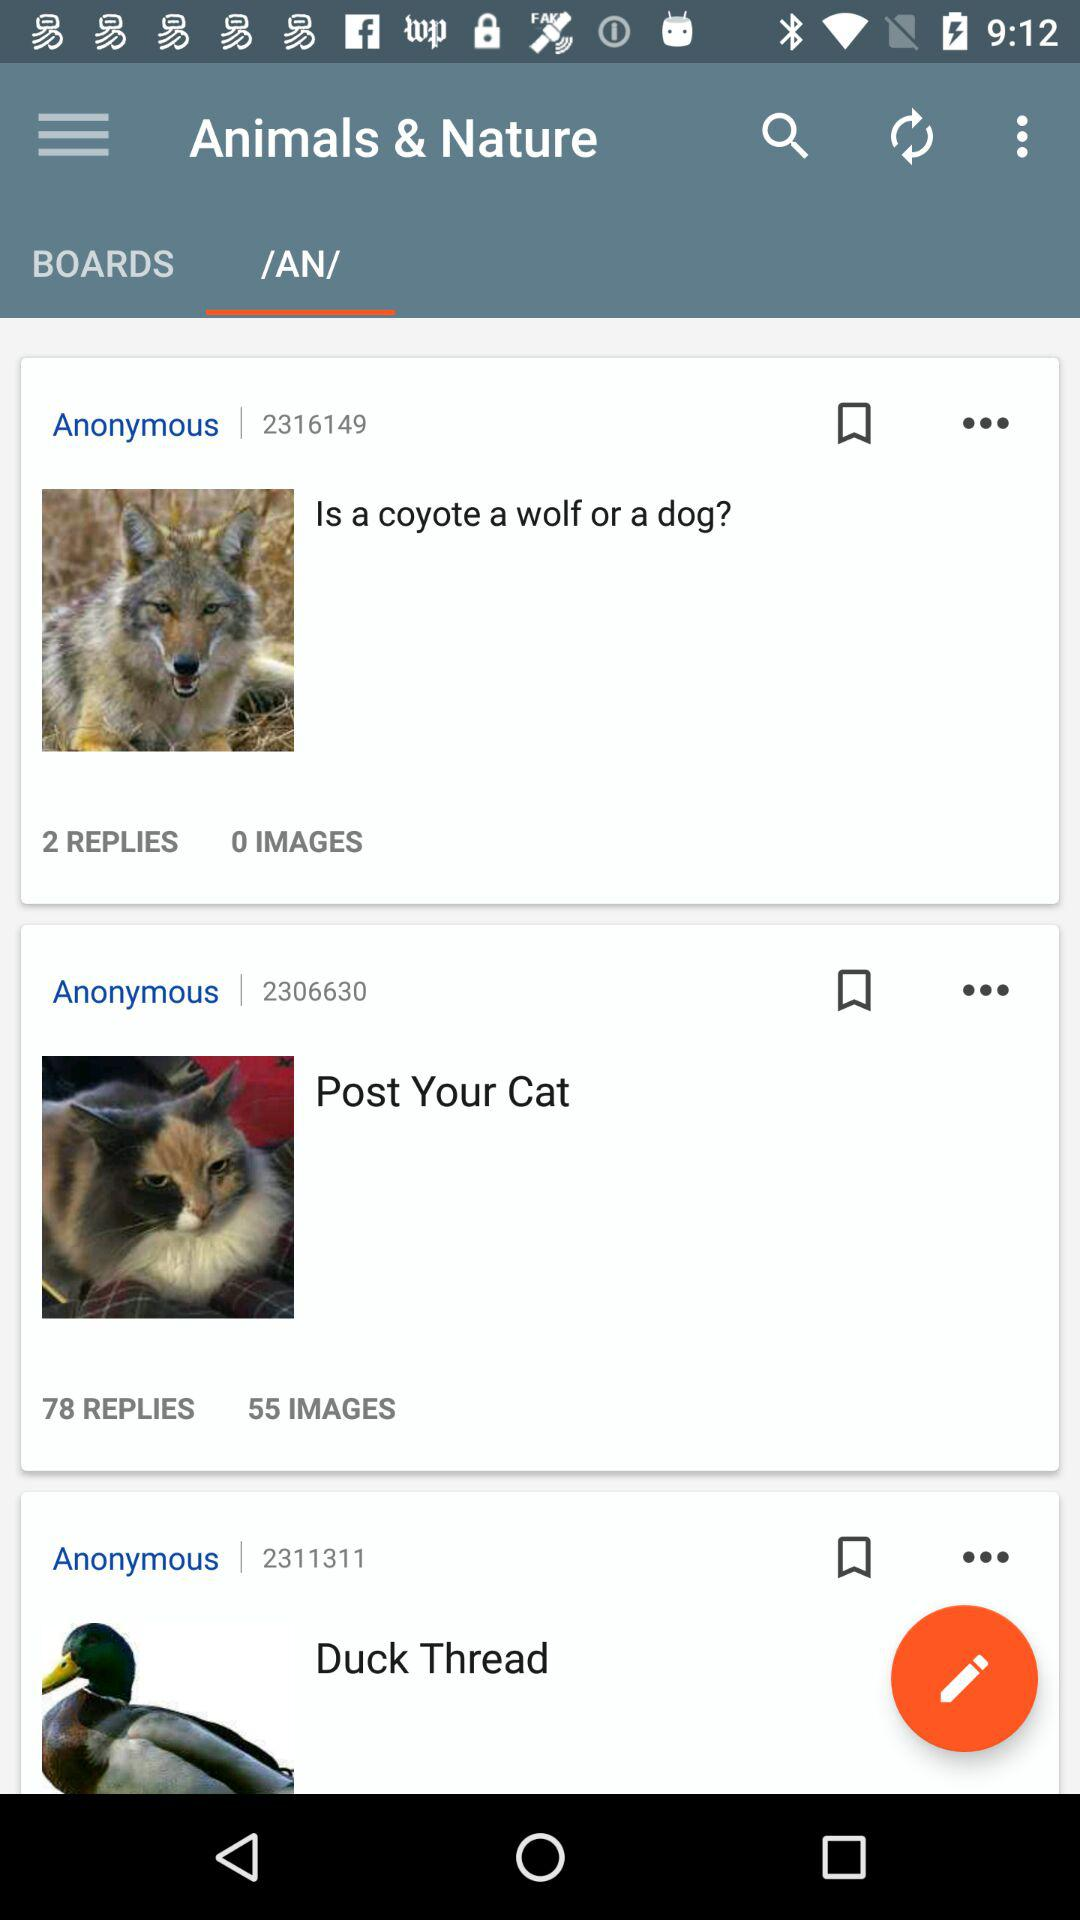Which tab is selected? The selected tab is /AN/. 